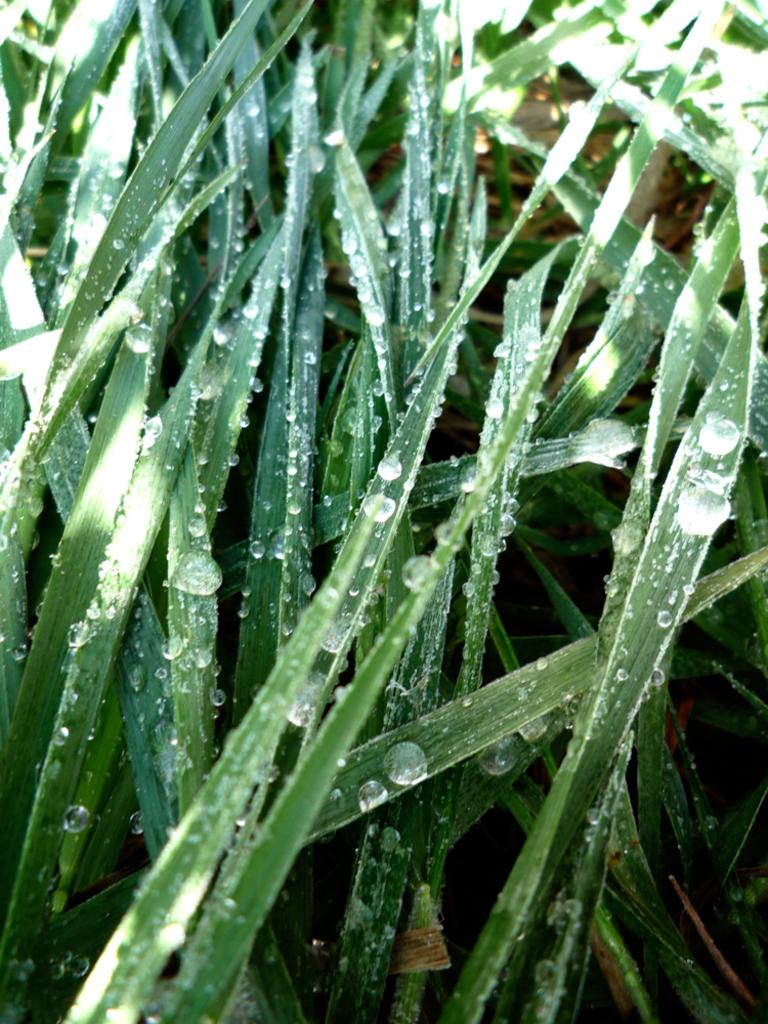What is located in the foreground of the image? There are plants in the foreground of the image. Can you describe the condition of the plants in the image? The plants have water droplets on them. What type of question can be seen floating near the plants in the image? There is no question visible in the image; it only features plants with water droplets. 